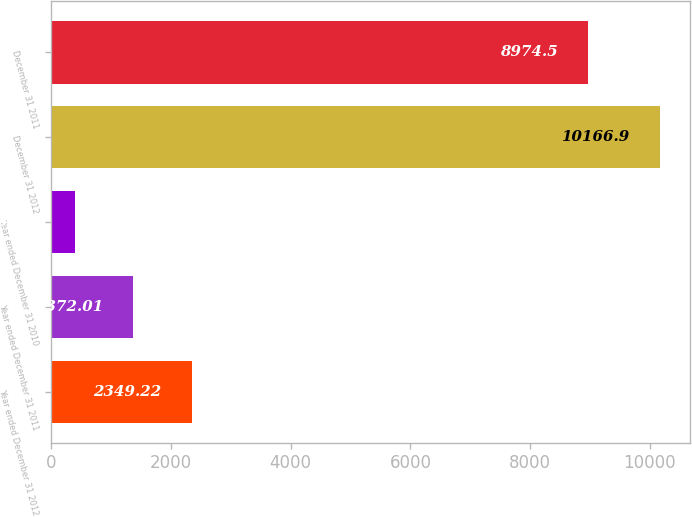Convert chart. <chart><loc_0><loc_0><loc_500><loc_500><bar_chart><fcel>Year ended December 31 2012<fcel>Year ended December 31 2011<fcel>Year ended December 31 2010<fcel>December 31 2012<fcel>December 31 2011<nl><fcel>2349.22<fcel>1372.01<fcel>394.8<fcel>10166.9<fcel>8974.5<nl></chart> 